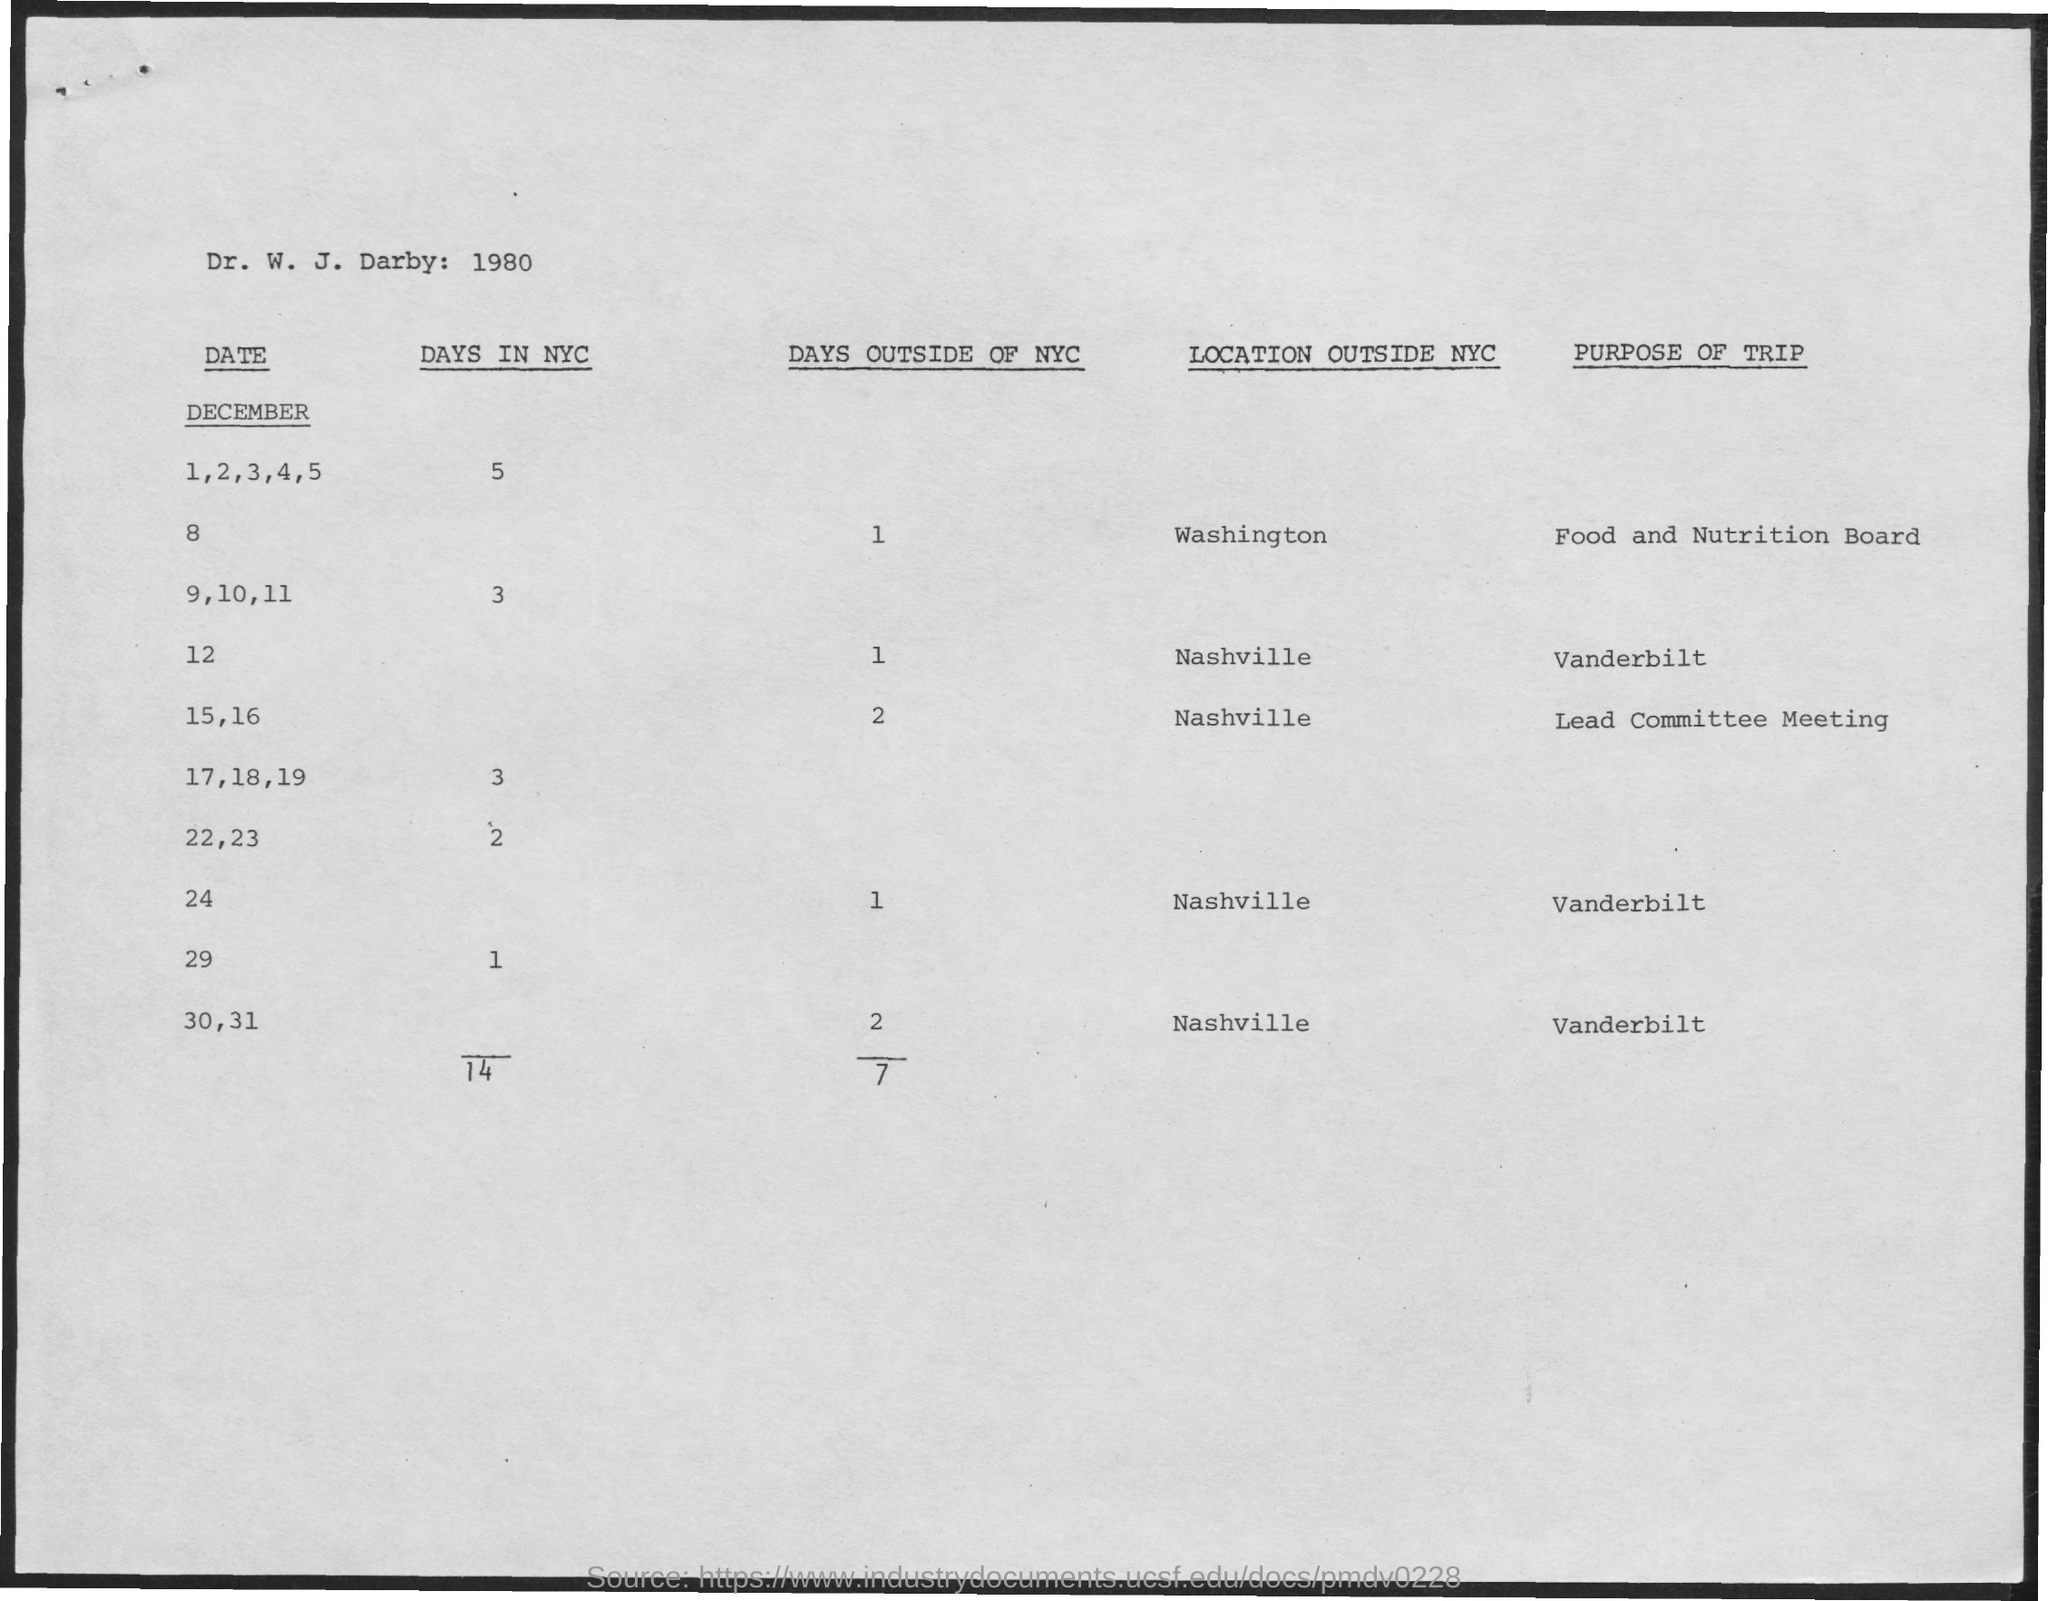What is the purpose of trip on December 15,16?
Keep it short and to the point. Lead Committee Meeting. On which day in December is the trip to Food and Nutrition Board?
Give a very brief answer. 8. 